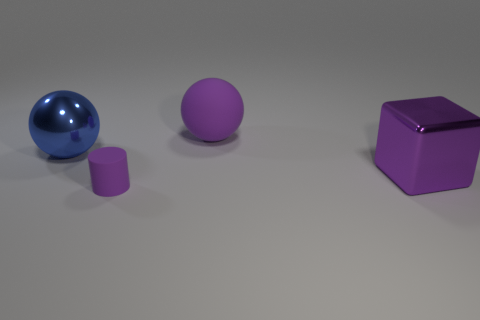There is a blue thing that is the same size as the cube; what material is it?
Your answer should be very brief. Metal. What is the material of the other object that is the same shape as the blue metal thing?
Give a very brief answer. Rubber. What number of other things are there of the same size as the purple cylinder?
Ensure brevity in your answer.  0. There is a metallic object that is the same color as the rubber ball; what is its size?
Your answer should be compact. Large. What number of big metallic objects have the same color as the metallic cube?
Your answer should be compact. 0. The small thing has what shape?
Your answer should be compact. Cylinder. There is a object that is left of the large purple rubber thing and in front of the blue metal sphere; what is its color?
Offer a very short reply. Purple. What is the cylinder made of?
Provide a succinct answer. Rubber. The large shiny object on the left side of the large cube has what shape?
Your answer should be very brief. Sphere. What color is the metal ball that is the same size as the purple cube?
Ensure brevity in your answer.  Blue. 